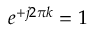<formula> <loc_0><loc_0><loc_500><loc_500>e ^ { + j 2 \pi k } = 1</formula> 